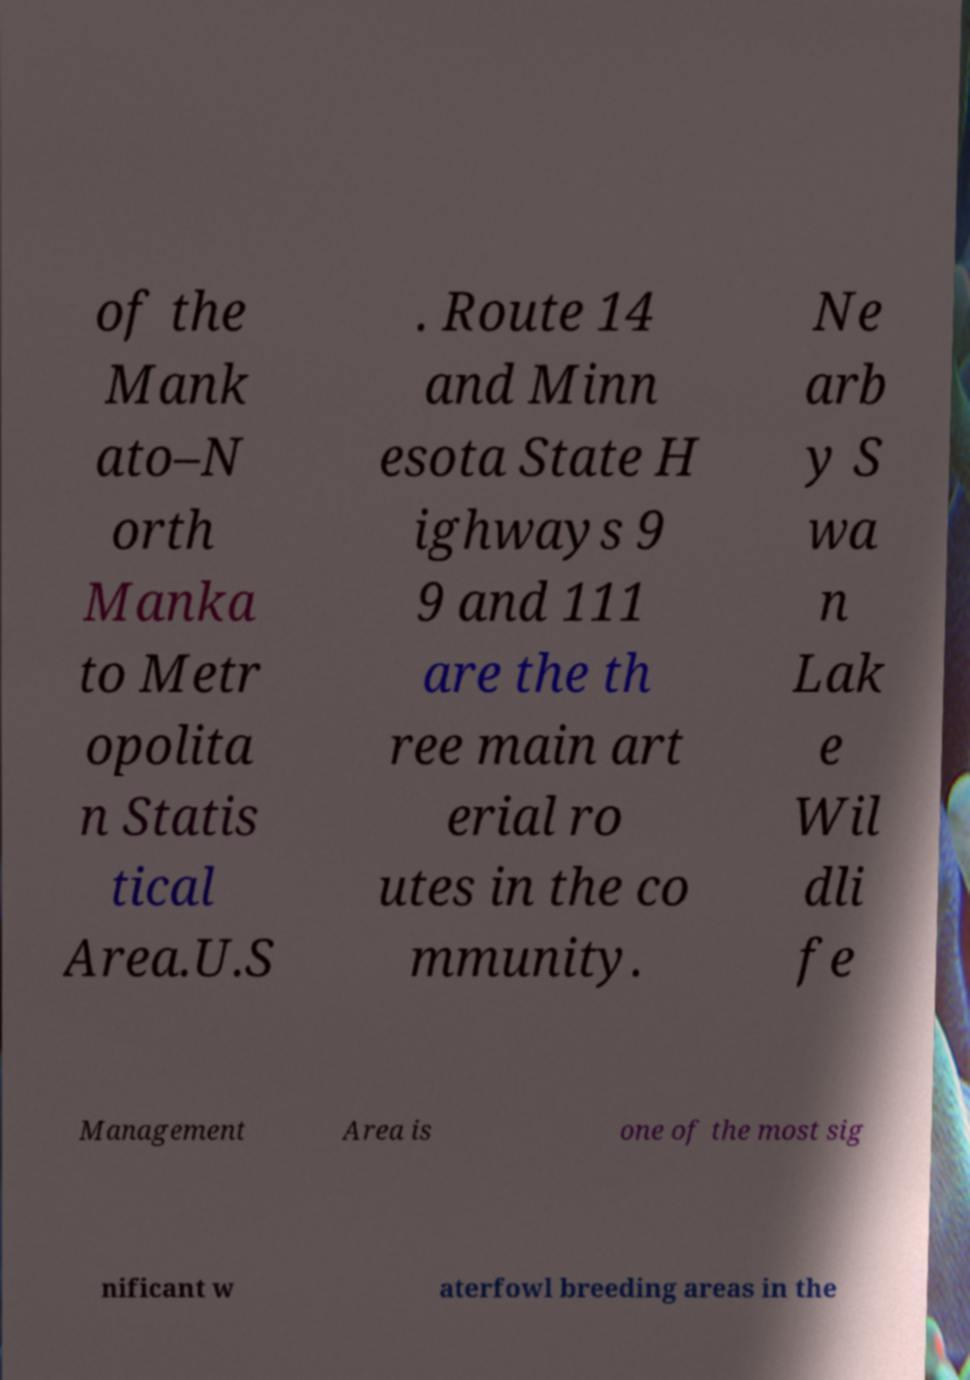Please identify and transcribe the text found in this image. of the Mank ato–N orth Manka to Metr opolita n Statis tical Area.U.S . Route 14 and Minn esota State H ighways 9 9 and 111 are the th ree main art erial ro utes in the co mmunity. Ne arb y S wa n Lak e Wil dli fe Management Area is one of the most sig nificant w aterfowl breeding areas in the 